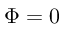Convert formula to latex. <formula><loc_0><loc_0><loc_500><loc_500>\Phi = 0</formula> 